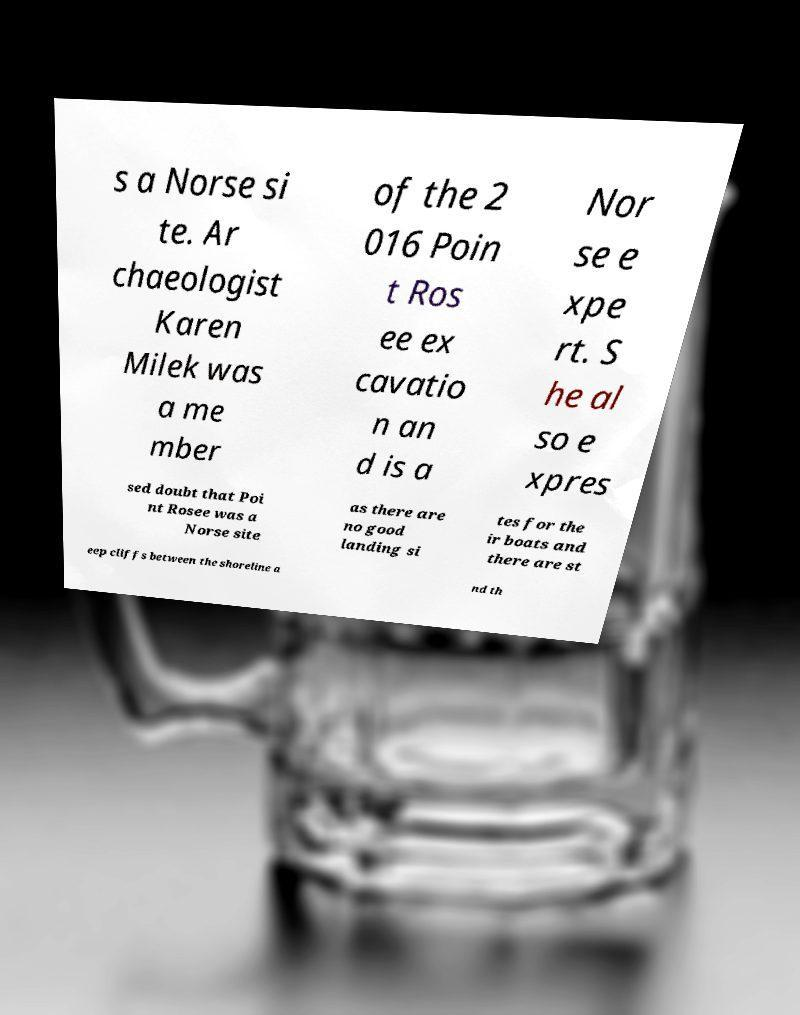Please identify and transcribe the text found in this image. s a Norse si te. Ar chaeologist Karen Milek was a me mber of the 2 016 Poin t Ros ee ex cavatio n an d is a Nor se e xpe rt. S he al so e xpres sed doubt that Poi nt Rosee was a Norse site as there are no good landing si tes for the ir boats and there are st eep cliffs between the shoreline a nd th 